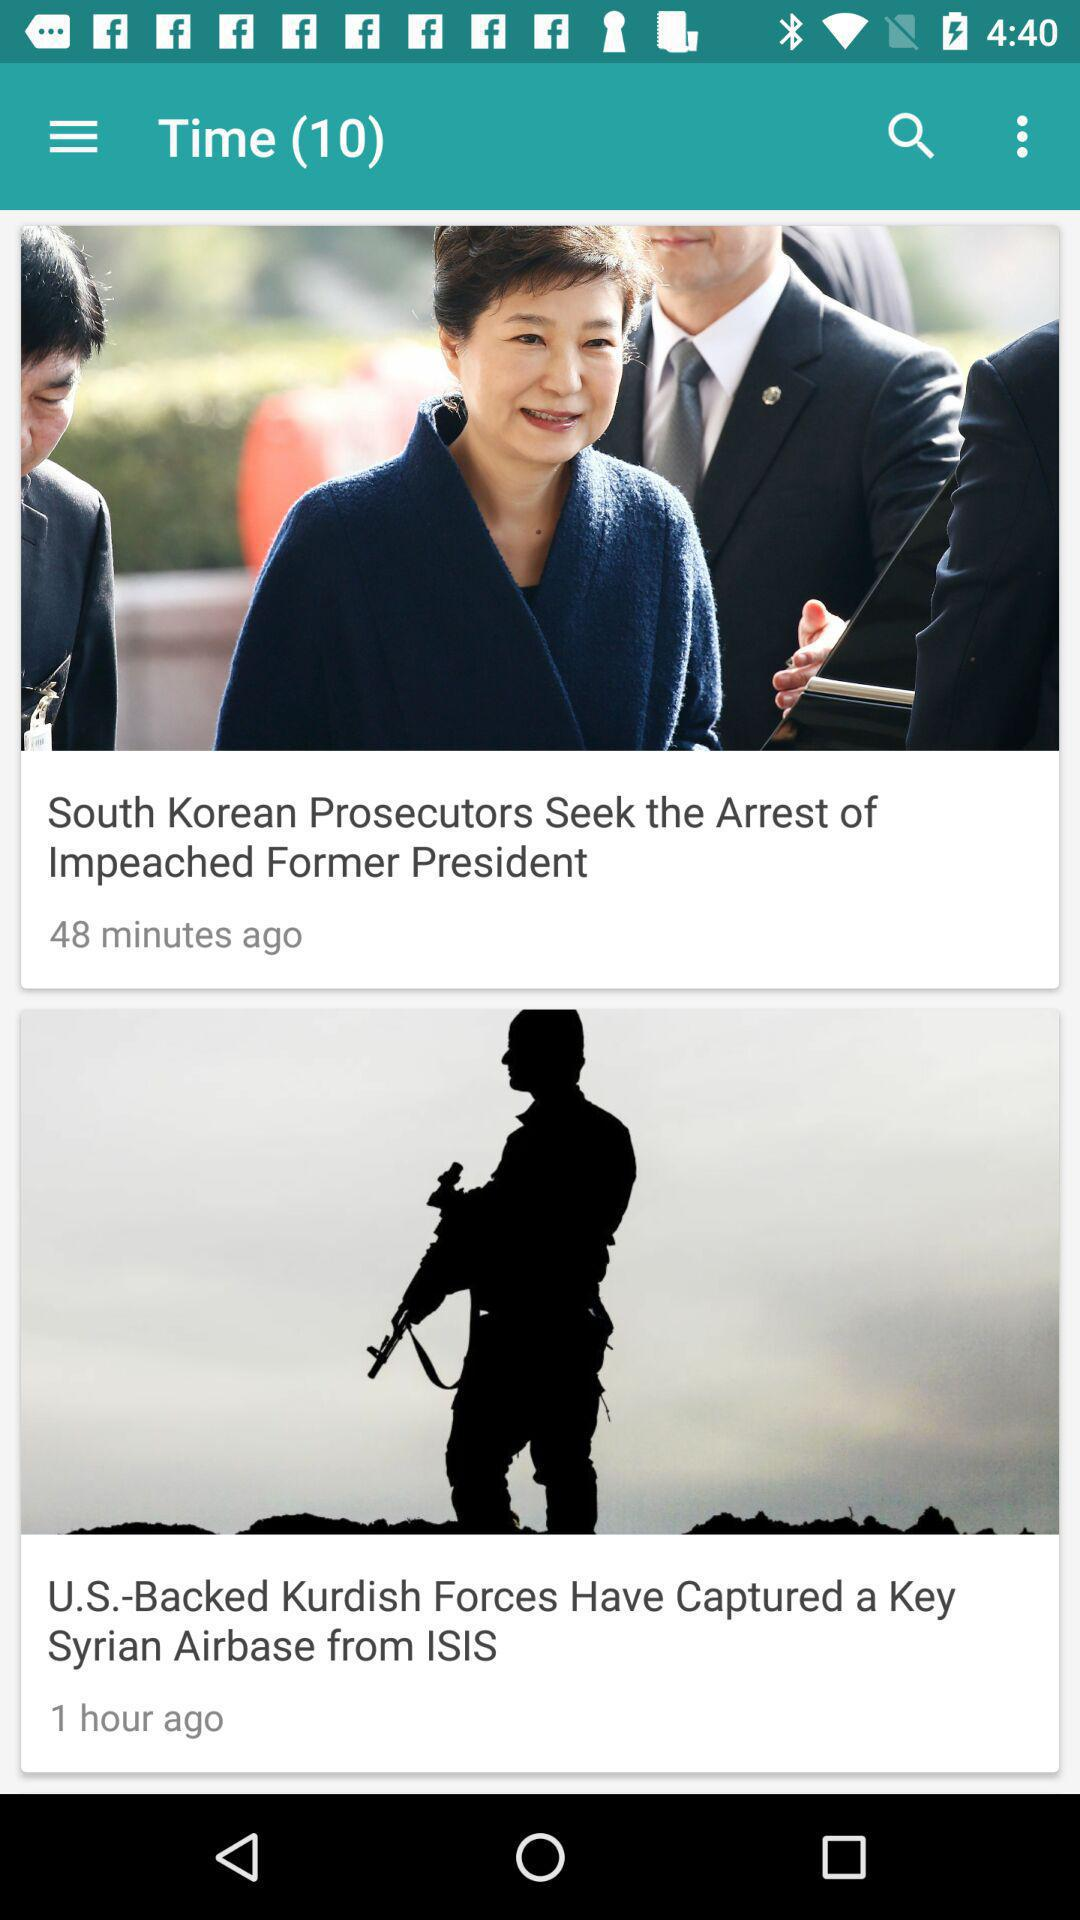When was the article "U.S.-Backed Kurdish Forces Have Captured a Key Syrian Airbase from ISIS" published? It was published 1 hour ago. 